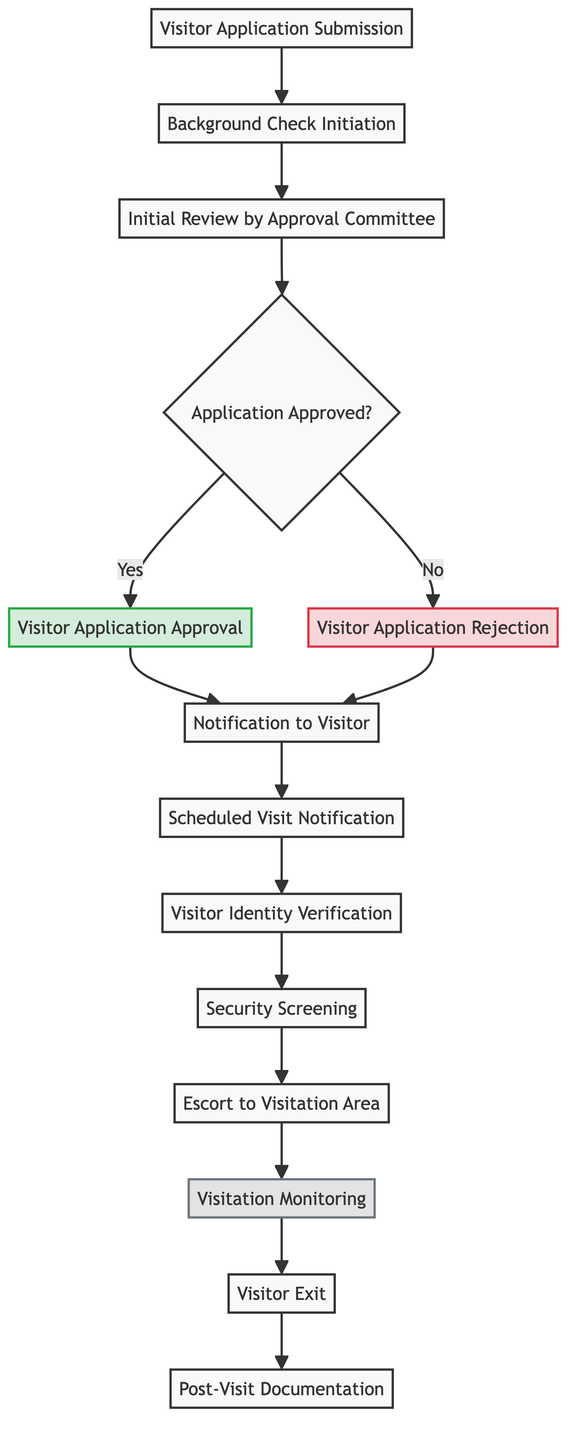What is the first step in the visitor approval procedure? The first step, as indicated in the flow chart, is "Visitor Application Submission". This starts the process where visitors formally submit their applications.
Answer: Visitor Application Submission How many nodes are present in this flow chart? By counting all the distinct steps listed in the diagram, there are a total of 13 nodes from the initial application submission to post-visit documentation.
Answer: 13 What happens if the application is approved? If the application is approved, the next step is "Visitor Application Approval". This indicates that the visitor meets the security and eligibility criteria for visiting an inmate.
Answer: Visitor Application Approval What is the term used for the process that occurs after identity verification? Following the "Visitor Identity Verification", the next process is "Security Screening". This process ensures that the visitor poses no security threat.
Answer: Security Screening Who is responsible for monitoring the visitation? The node titled "Visitation Monitoring" indicates that correctional staff are responsible for monitoring the actual visit to ensure compliance.
Answer: Correctional staff If a visitor's application is rejected, what is the subsequent step? After "Visitor Application Rejection", the next step is still "Notification to Visitor", indicating that whether approved or rejected, the visitor receives notification of their application status.
Answer: Notification to Visitor What does the node labeled "Post-Visit Documentation" signify? The "Post-Visit Documentation" node signifies that after the visitation, a report is generated to document visit details and any incidents that occurred during the visit.
Answer: A report is generated Which node represents the process of escorting visitors? The node "Escort to Visitation Area" represents the process where approved visitors are escorted by a correctional officer to the designated area for their visit.
Answer: Escort to Visitation Area What decision is made after the initial review by the approval committee? After the "Initial Review by Approval Committee", a decision is made at the "Application Approved?" node, determining whether the application is approved or rejected.
Answer: Application Approved? 